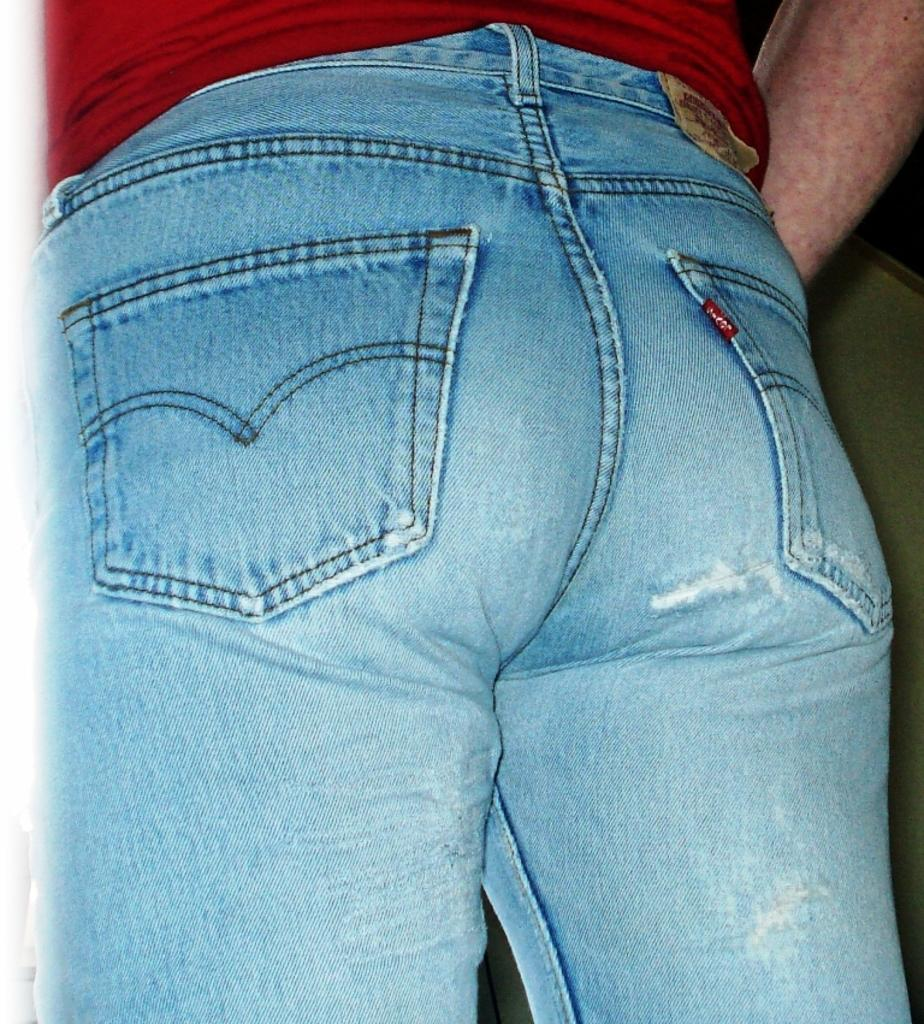What is the main subject of the image? The main subject of the image is a person standing. What can be observed about the background of the image? The background of the image is dark. What type of popcorn is being served to the committee in the image? There is no committee or popcorn present in the image; it only features a person standing against a dark background. 